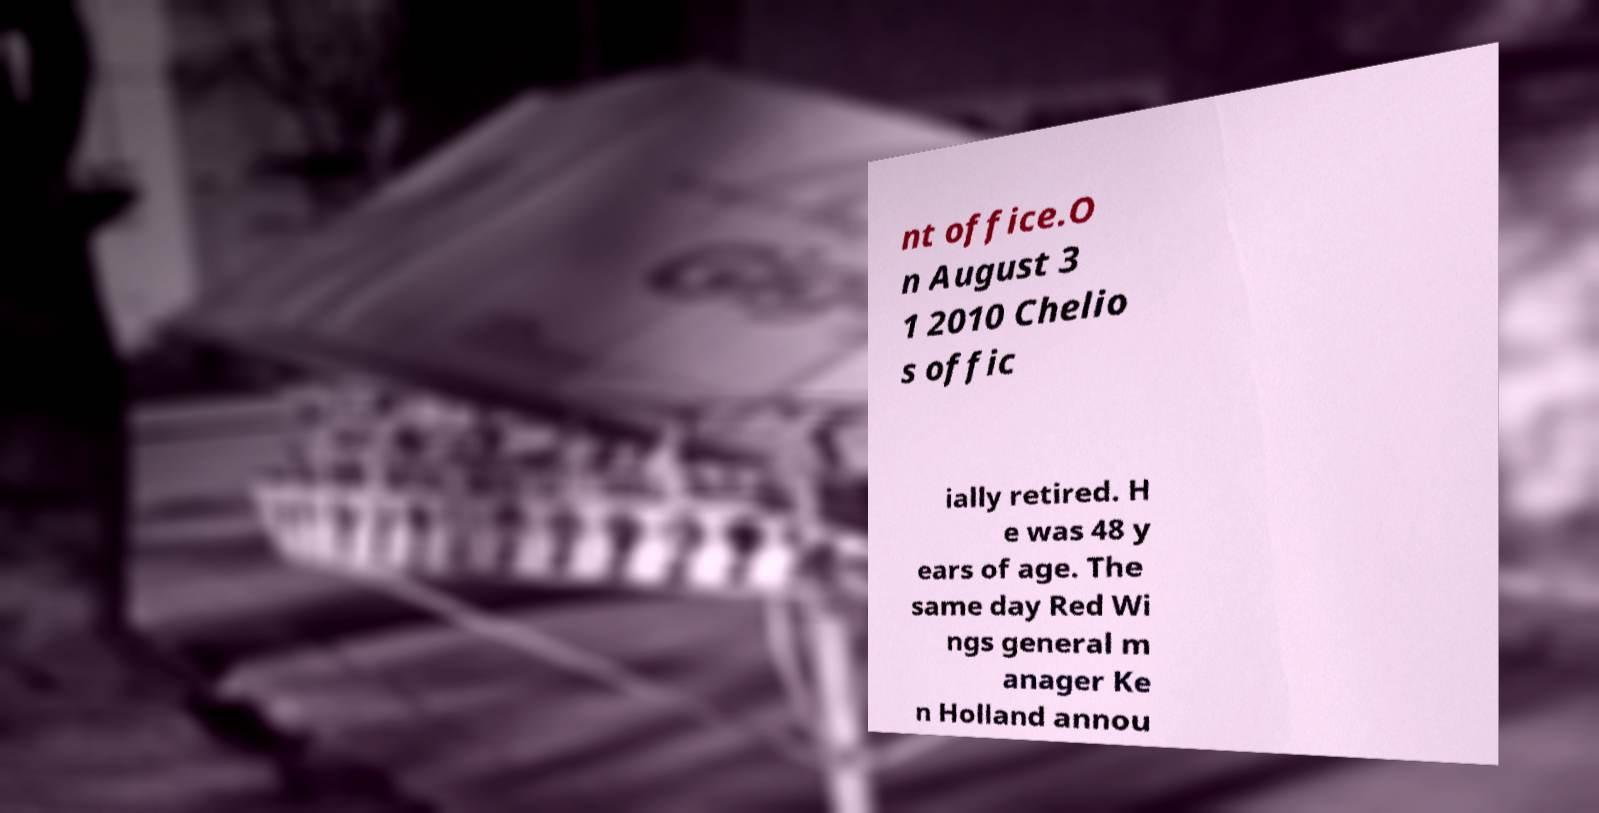Can you read and provide the text displayed in the image?This photo seems to have some interesting text. Can you extract and type it out for me? nt office.O n August 3 1 2010 Chelio s offic ially retired. H e was 48 y ears of age. The same day Red Wi ngs general m anager Ke n Holland annou 